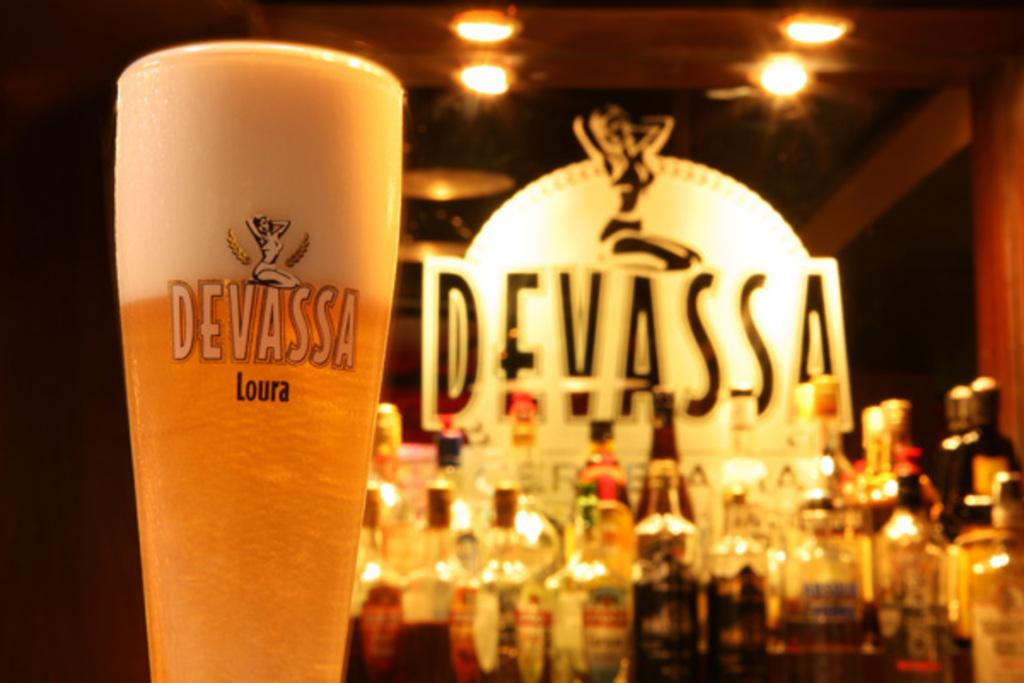Provide a one-sentence caption for the provided image. A glass of Devassa beer with foam at the top. 